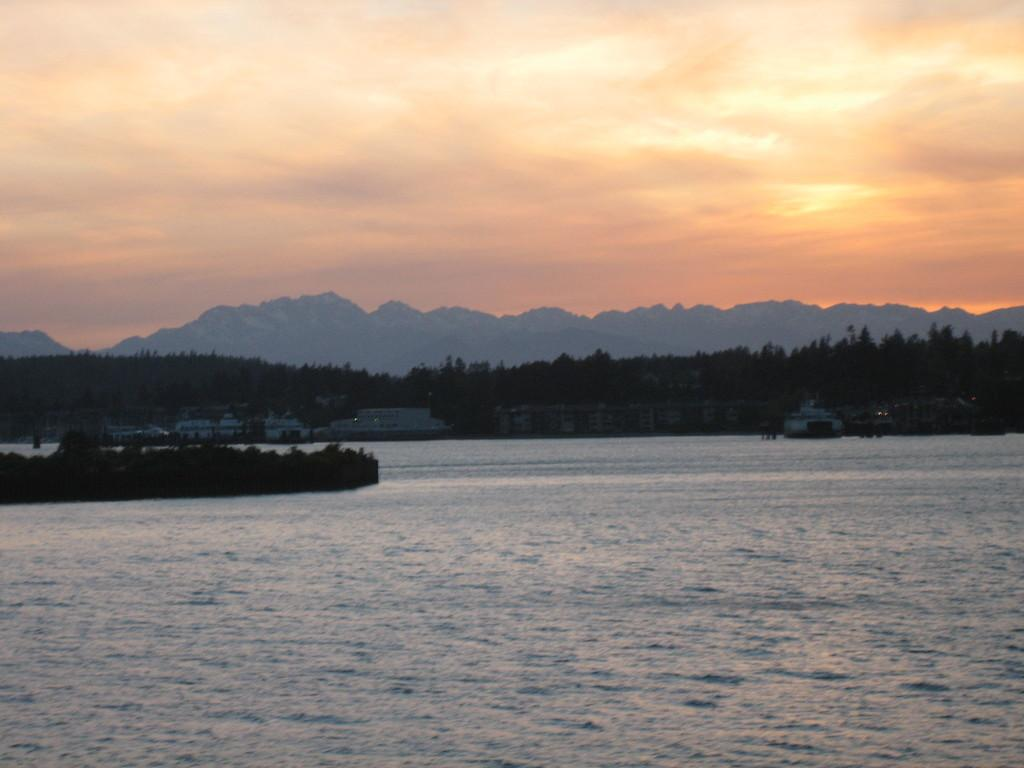What is in the foreground of the image? There is water in the foreground of the image. What can be seen in the background of the image? There are buildings, ships, mountains, and the sky visible in the background of the image. Can you describe the sky in the image? The sky is visible in the background of the image, and there is a cloud present. What type of net is being used to pull the story in the image? There is no net or story present in the image; it features water, buildings, ships, mountains, and a cloudy sky. 